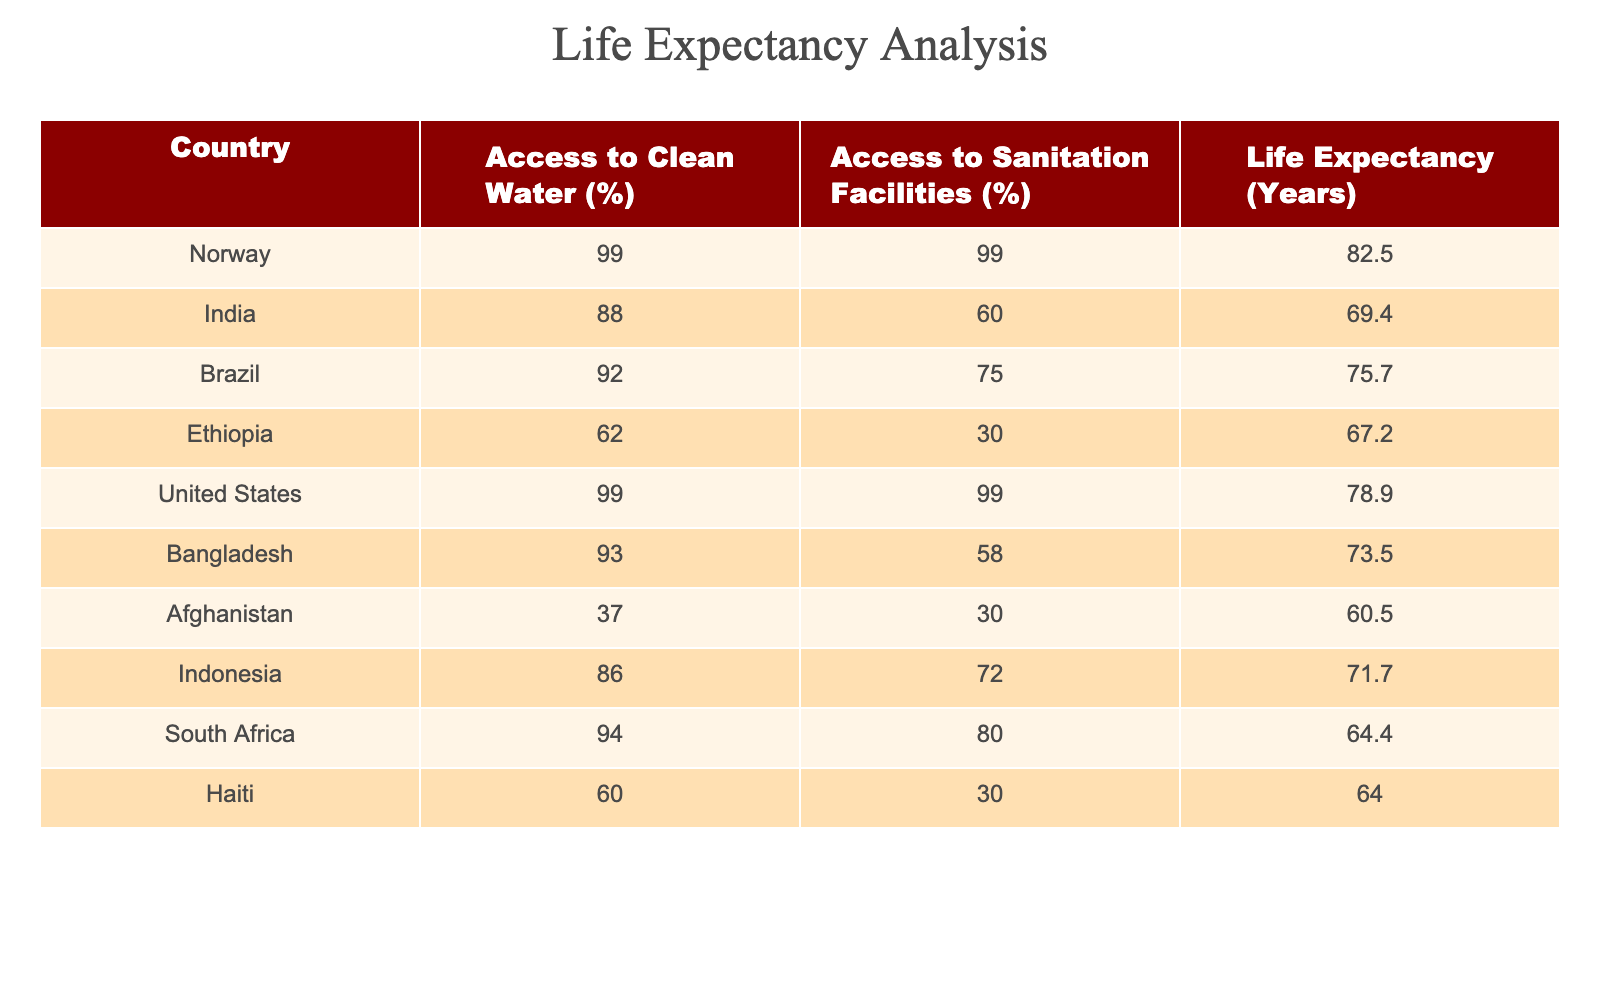what is the life expectancy of India? The table lists the life expectancy for India as 69.4 years.
Answer: 69.4 years which country has the lowest access to sanitation facilities? The table shows that Afghanistan has the lowest access to sanitation facilities at 30%.
Answer: Afghanistan what is the average life expectancy of the countries listed with access to clean water above 90%? The countries with access to clean water above 90% are Norway, Brazil, the United States, and Bangladesh. Their life expectancies are 82.5, 75.7, 78.9, and 73.5 years respectively. The average is (82.5 + 75.7 + 78.9 + 73.5) / 4 = 77.4 years.
Answer: 77.4 years is it true that Ethiopia has a higher life expectancy than Haiti? Ethiopia's life expectancy is 67.2 years, while Haiti's is 64.0 years. Thus, it is true that Ethiopia has a higher life expectancy than Haiti.
Answer: Yes which country has both the highest access to clean water and the highest life expectancy? The table states that Norway and the United States both have 99% access to clean water. Norway has a life expectancy of 82.5 years, which is higher than the United States' 78.9 years. Therefore, Norway has both the highest access to clean water and the highest life expectancy.
Answer: Norway 